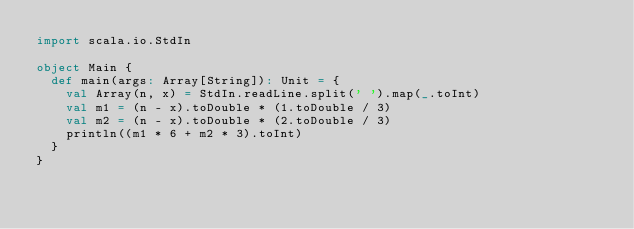<code> <loc_0><loc_0><loc_500><loc_500><_Scala_>import scala.io.StdIn

object Main {
  def main(args: Array[String]): Unit = {
    val Array(n, x) = StdIn.readLine.split(' ').map(_.toInt)
    val m1 = (n - x).toDouble * (1.toDouble / 3)
    val m2 = (n - x).toDouble * (2.toDouble / 3)
    println((m1 * 6 + m2 * 3).toInt)
  }
}</code> 